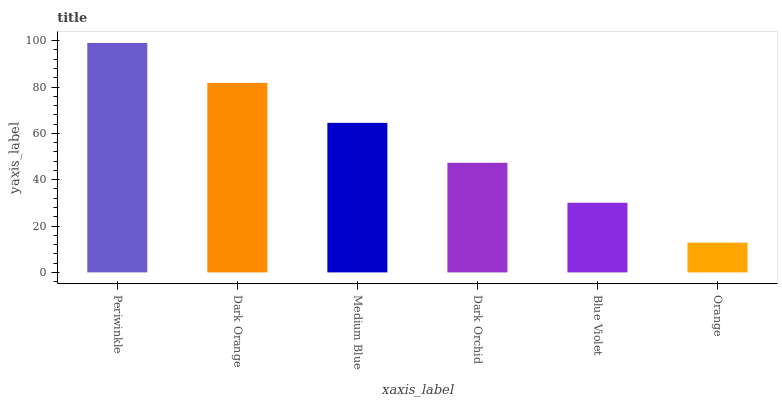Is Dark Orange the minimum?
Answer yes or no. No. Is Dark Orange the maximum?
Answer yes or no. No. Is Periwinkle greater than Dark Orange?
Answer yes or no. Yes. Is Dark Orange less than Periwinkle?
Answer yes or no. Yes. Is Dark Orange greater than Periwinkle?
Answer yes or no. No. Is Periwinkle less than Dark Orange?
Answer yes or no. No. Is Medium Blue the high median?
Answer yes or no. Yes. Is Dark Orchid the low median?
Answer yes or no. Yes. Is Dark Orchid the high median?
Answer yes or no. No. Is Medium Blue the low median?
Answer yes or no. No. 